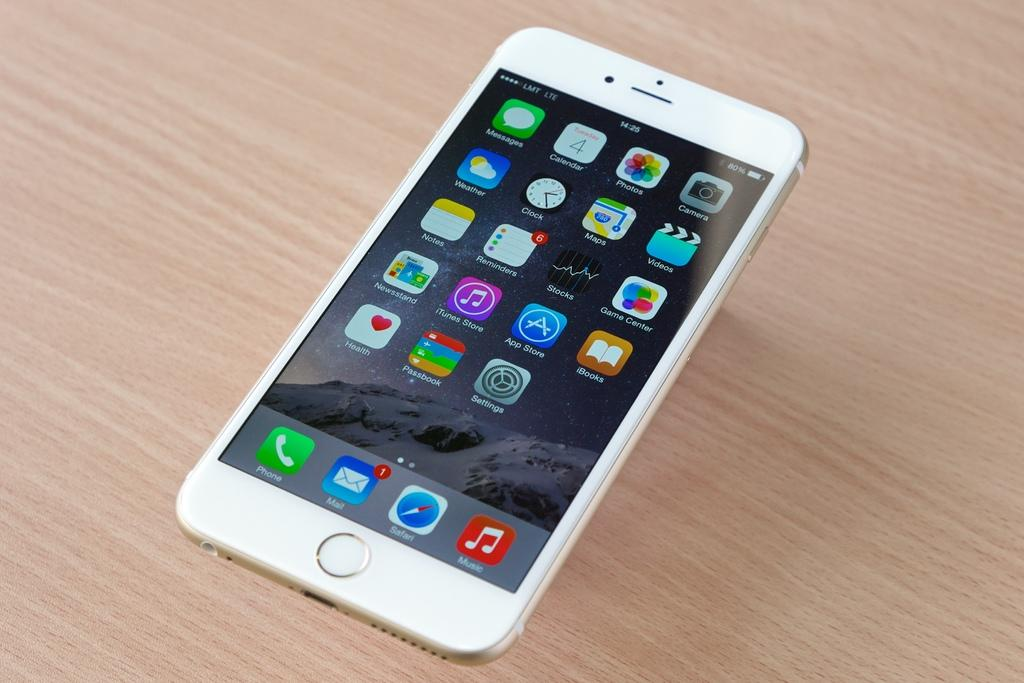<image>
Share a concise interpretation of the image provided. A phone shows that the mail app has 1 notification. 